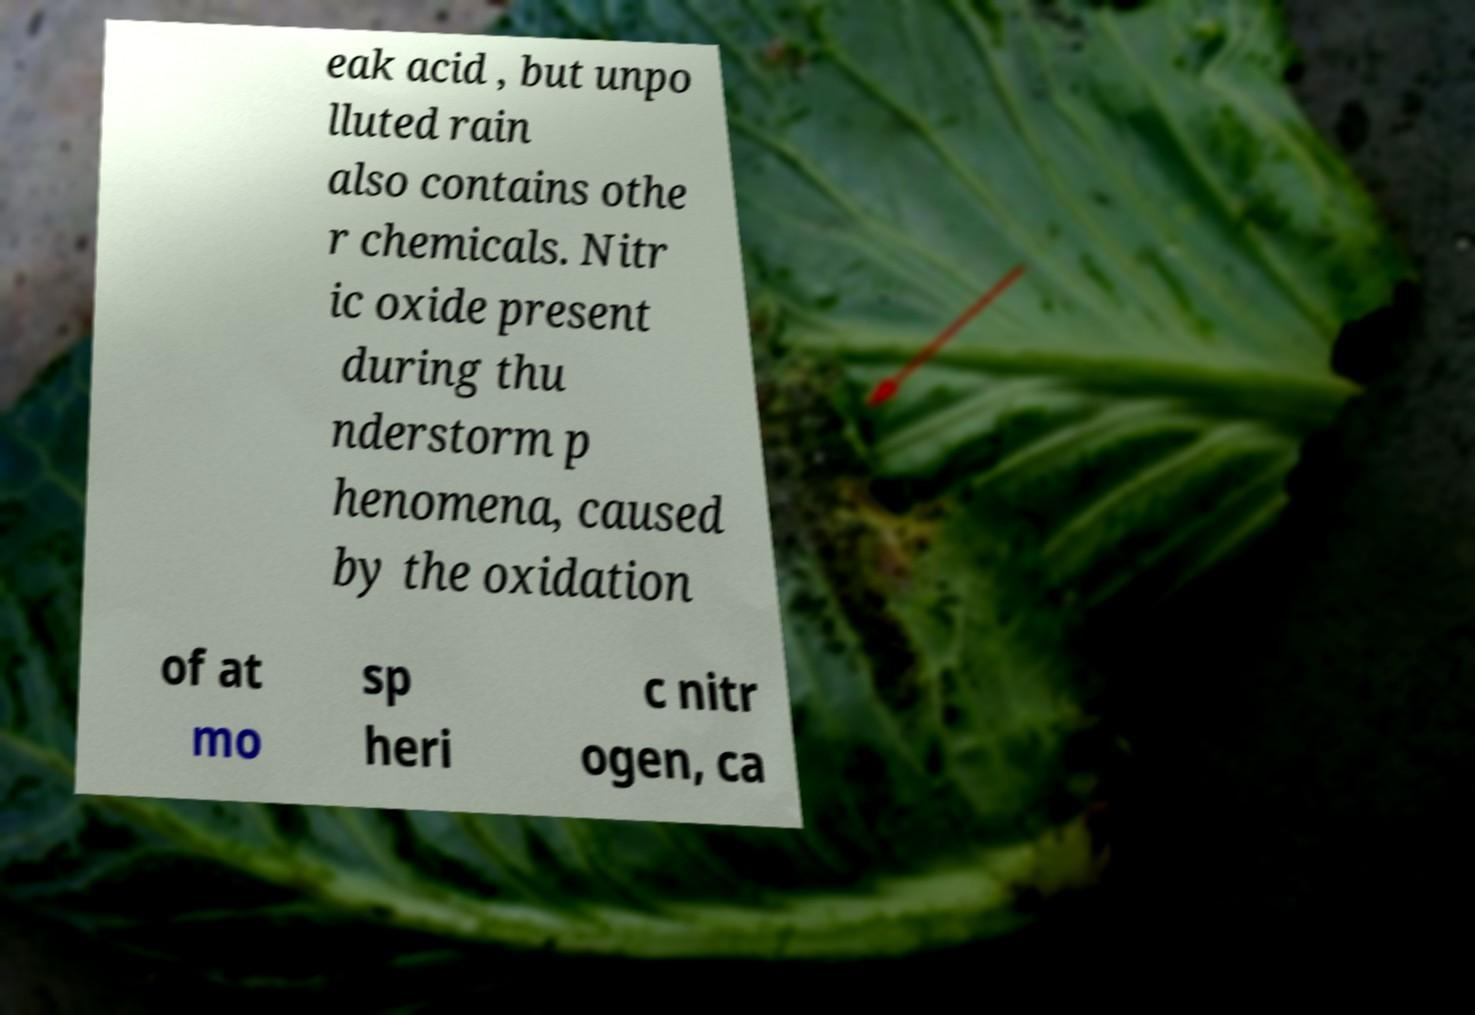Can you read and provide the text displayed in the image?This photo seems to have some interesting text. Can you extract and type it out for me? eak acid , but unpo lluted rain also contains othe r chemicals. Nitr ic oxide present during thu nderstorm p henomena, caused by the oxidation of at mo sp heri c nitr ogen, ca 